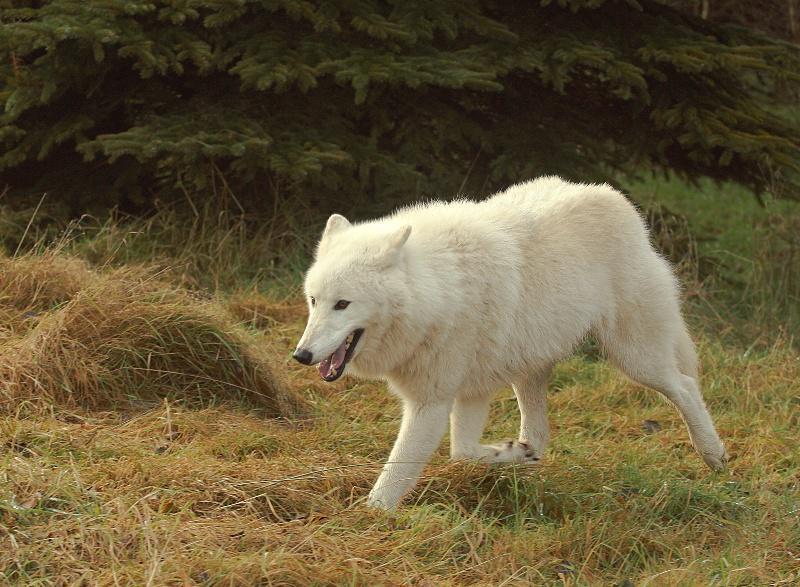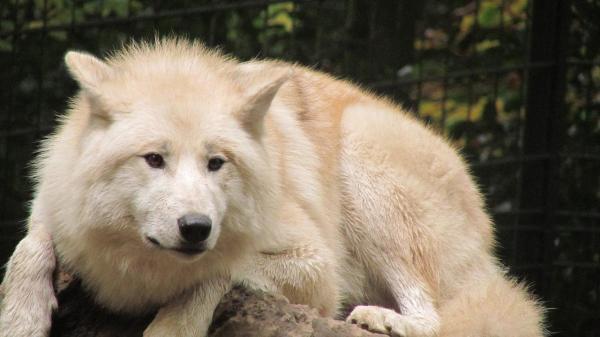The first image is the image on the left, the second image is the image on the right. For the images displayed, is the sentence "At least one wolf is hovering over dead prey." factually correct? Answer yes or no. No. The first image is the image on the left, the second image is the image on the right. Analyze the images presented: Is the assertion "An image shows a wolf standing with its head bent down, behind part of a carcass." valid? Answer yes or no. No. 